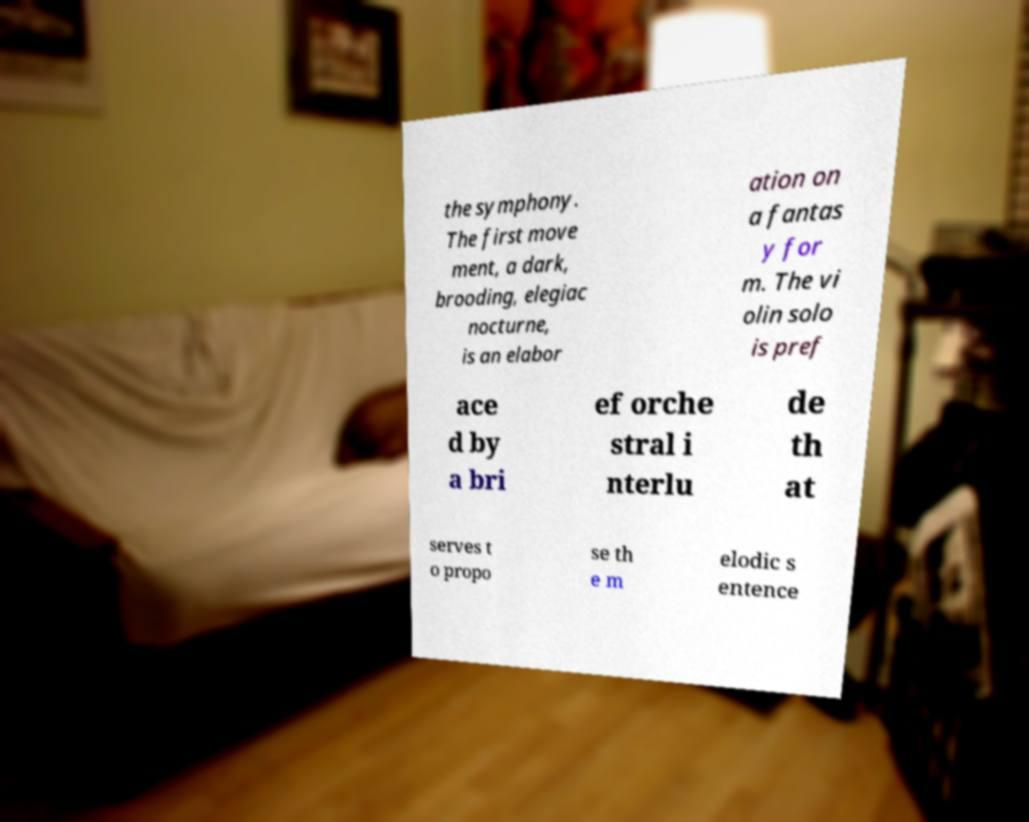There's text embedded in this image that I need extracted. Can you transcribe it verbatim? the symphony. The first move ment, a dark, brooding, elegiac nocturne, is an elabor ation on a fantas y for m. The vi olin solo is pref ace d by a bri ef orche stral i nterlu de th at serves t o propo se th e m elodic s entence 